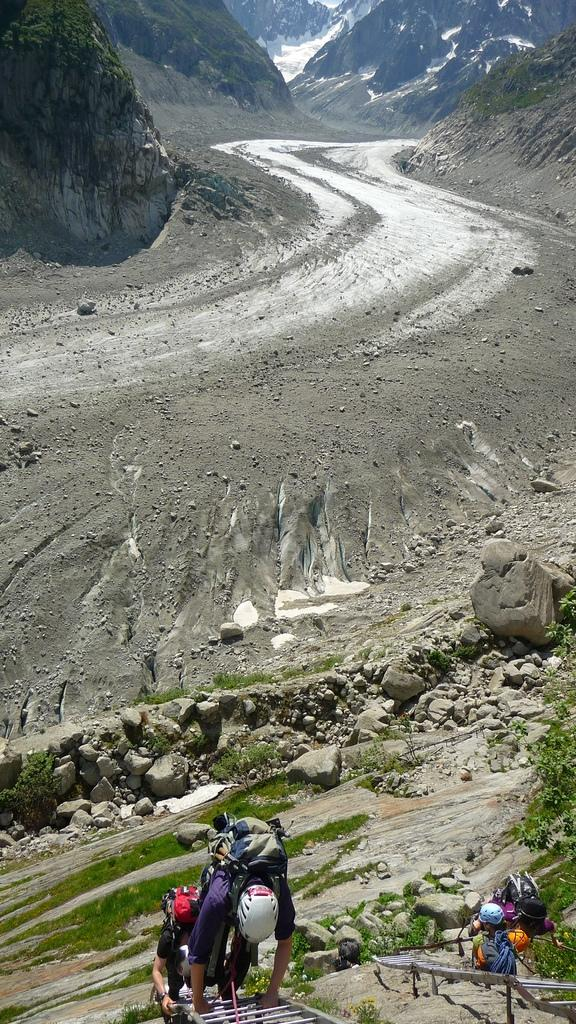What are the people in the foreground of the image doing? The people in the foreground of the image are climbing on ladders. What can be seen in the background of the image? In the background of the image, there are stones, grassland, and mountains. Can you describe the terrain in the background of the image? The terrain in the background of the image includes grassland and mountains. How does the image depict the border between two countries? The image does not depict a border between two countries; it shows people climbing on ladders and a background with stones, grassland, and mountains. What type of attack is being carried out in the image? There is no attack depicted in the image; it shows people climbing on ladders and a background with stones, grassland, and mountains. 